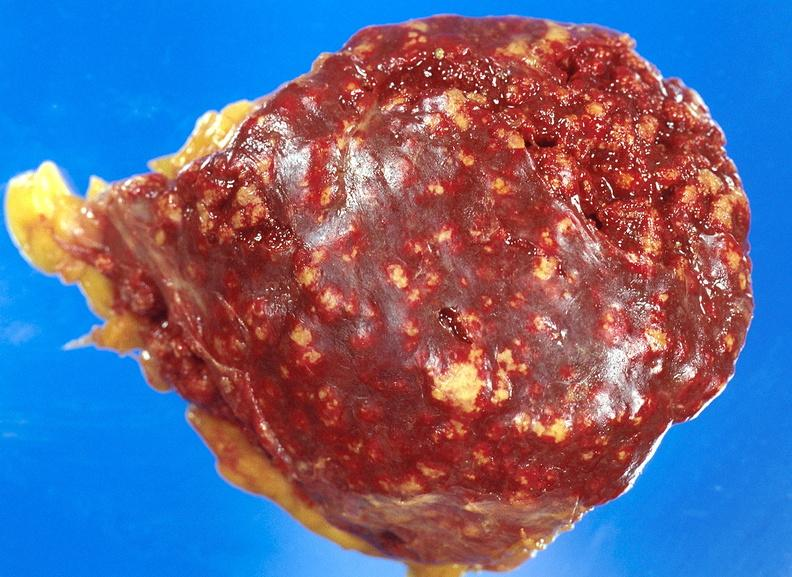s hematologic present?
Answer the question using a single word or phrase. Yes 